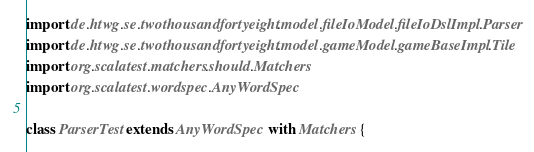Convert code to text. <code><loc_0><loc_0><loc_500><loc_500><_Scala_>
import de.htwg.se.twothousandfortyeight.model.fileIoModel.fileIoDslImpl.Parser
import de.htwg.se.twothousandfortyeight.model.gameModel.gameBaseImpl.Tile
import org.scalatest.matchers.should.Matchers
import org.scalatest.wordspec.AnyWordSpec

class ParserTest extends AnyWordSpec with Matchers {</code> 